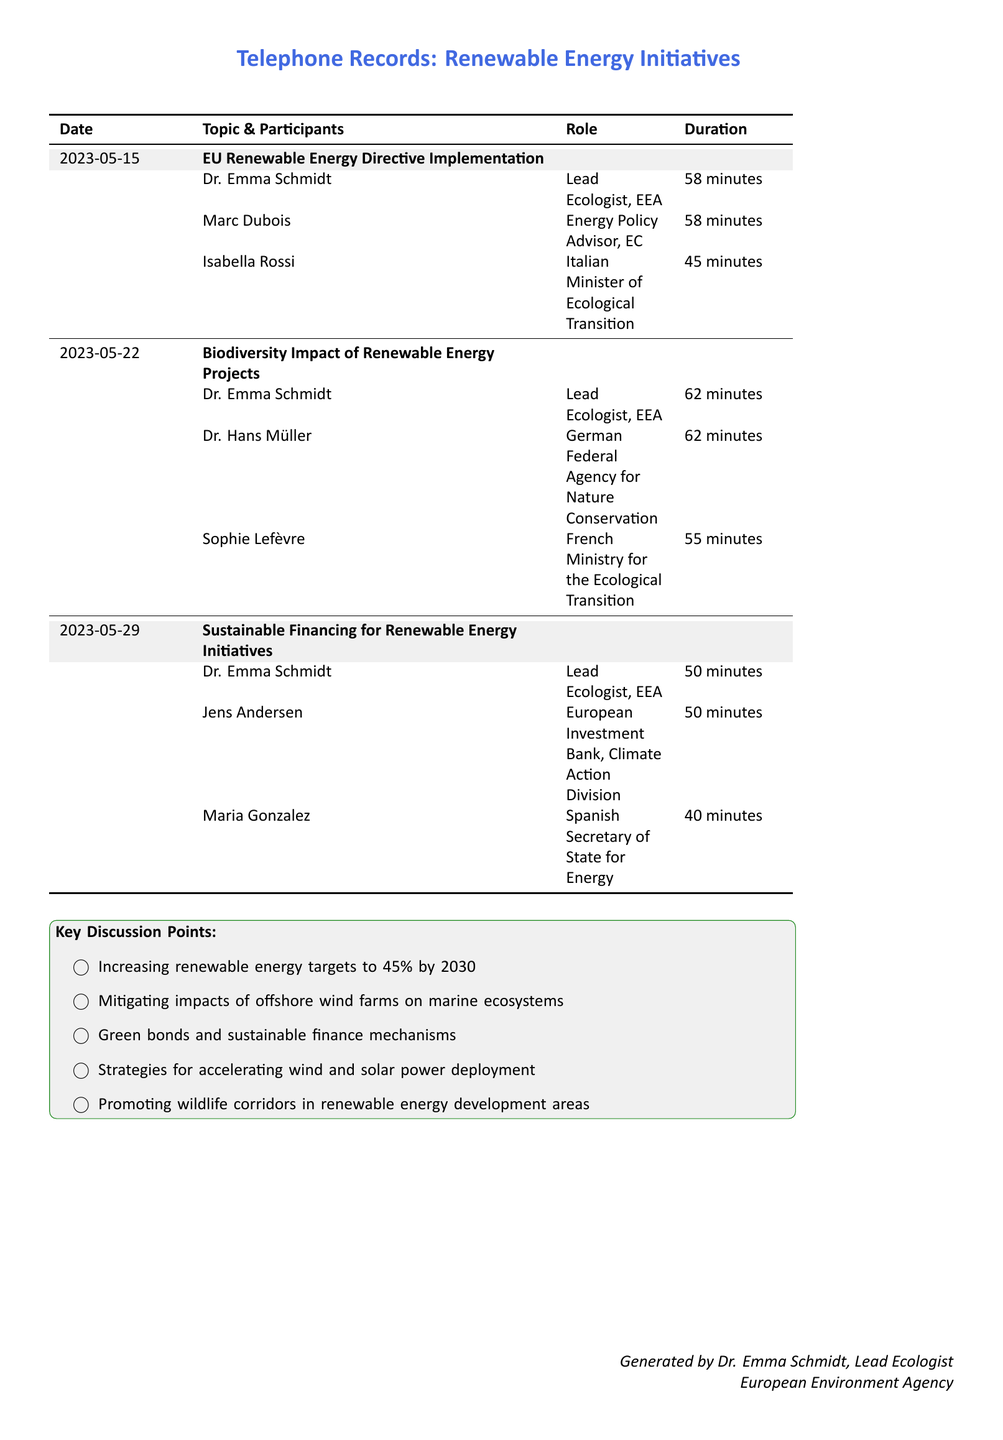What is the date of the first teleconference session? The date can be found in the first row of the document, which lists the session on EU Renewable Energy Directive Implementation.
Answer: 2023-05-15 Who was the lead ecologist participating in the sessions? The document lists Dr. Emma Schmidt as the Lead Ecologist for each teleconference session.
Answer: Dr. Emma Schmidt What was the topic of the session on May 22, 2023? The topic for that date is specified in the second row of the document, which details the discussion focus.
Answer: Biodiversity Impact of Renewable Energy Projects How long did the session on Sustainable Financing last? The duration of that specific session is noted in the document under the Sustainable Financing table entry.
Answer: 50 minutes Which participant was from the European Investment Bank? The document identifies Jens Andersen as the representative from the European Investment Bank.
Answer: Jens Andersen What percentage of renewable energy targets is being discussed for 2030? The document highlights a specific target percentage during the key discussion points section.
Answer: 45% How many participants were involved in the Biodiversity session? The number of unique participants listed under the Biodiversity Impact section can be counted from the document.
Answer: 3 What role did Isabella Rossi play in the sessions? The document specifies her title and function in relation to the teleconference participation.
Answer: Italian Minister of Ecological Transition What key point relates to marine ecosystems? One of the key discussion points mentions the impacts of offshore wind farms specifically on marine ecosystems.
Answer: Mitigating impacts of offshore wind farms on marine ecosystems 